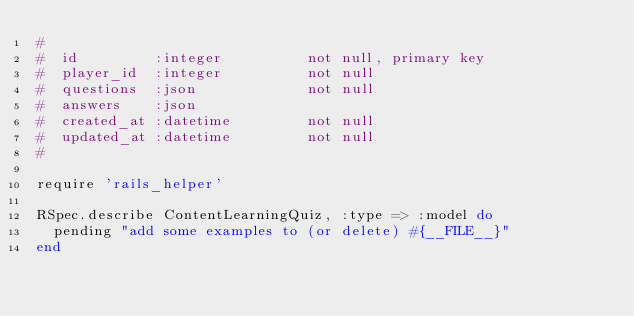Convert code to text. <code><loc_0><loc_0><loc_500><loc_500><_Ruby_>#
#  id         :integer          not null, primary key
#  player_id  :integer          not null
#  questions  :json             not null
#  answers    :json
#  created_at :datetime         not null
#  updated_at :datetime         not null
#

require 'rails_helper'

RSpec.describe ContentLearningQuiz, :type => :model do
  pending "add some examples to (or delete) #{__FILE__}"
end
</code> 